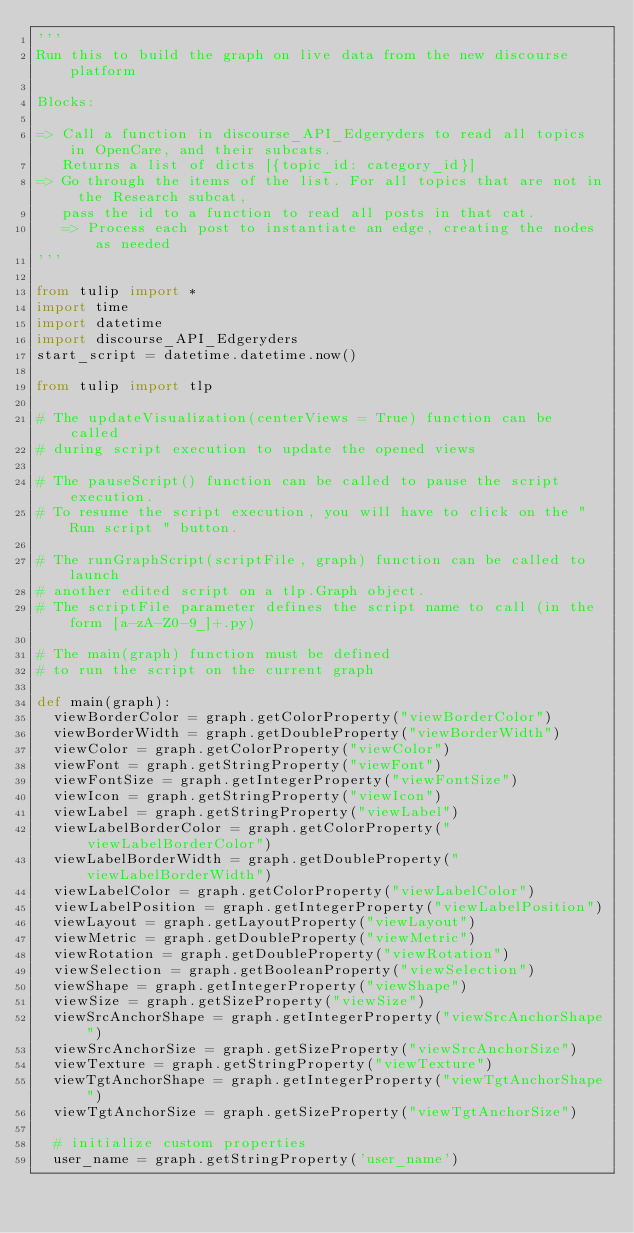<code> <loc_0><loc_0><loc_500><loc_500><_Python_>'''
Run this to build the graph on live data from the new discourse platform

Blocks:

=> Call a function in discourse_API_Edgeryders to read all topics in OpenCare, and their subcats. 
   Returns a list of dicts [{topic_id: category_id}]
=> Go through the items of the list. For all topics that are not in the Research subcat, 
   pass the id to a function to read all posts in that cat.
   => Process each post to instantiate an edge, creating the nodes as needed
'''

from tulip import *
import time
import datetime
import discourse_API_Edgeryders
start_script = datetime.datetime.now()

from tulip import tlp

# The updateVisualization(centerViews = True) function can be called
# during script execution to update the opened views

# The pauseScript() function can be called to pause the script execution.
# To resume the script execution, you will have to click on the "Run script " button.

# The runGraphScript(scriptFile, graph) function can be called to launch
# another edited script on a tlp.Graph object.
# The scriptFile parameter defines the script name to call (in the form [a-zA-Z0-9_]+.py)

# The main(graph) function must be defined 
# to run the script on the current graph

def main(graph): 
  viewBorderColor = graph.getColorProperty("viewBorderColor")
  viewBorderWidth = graph.getDoubleProperty("viewBorderWidth")
  viewColor = graph.getColorProperty("viewColor")
  viewFont = graph.getStringProperty("viewFont")
  viewFontSize = graph.getIntegerProperty("viewFontSize")
  viewIcon = graph.getStringProperty("viewIcon")
  viewLabel = graph.getStringProperty("viewLabel")
  viewLabelBorderColor = graph.getColorProperty("viewLabelBorderColor")
  viewLabelBorderWidth = graph.getDoubleProperty("viewLabelBorderWidth")
  viewLabelColor = graph.getColorProperty("viewLabelColor")
  viewLabelPosition = graph.getIntegerProperty("viewLabelPosition")
  viewLayout = graph.getLayoutProperty("viewLayout")
  viewMetric = graph.getDoubleProperty("viewMetric")
  viewRotation = graph.getDoubleProperty("viewRotation")
  viewSelection = graph.getBooleanProperty("viewSelection")
  viewShape = graph.getIntegerProperty("viewShape")
  viewSize = graph.getSizeProperty("viewSize")
  viewSrcAnchorShape = graph.getIntegerProperty("viewSrcAnchorShape")
  viewSrcAnchorSize = graph.getSizeProperty("viewSrcAnchorSize")
  viewTexture = graph.getStringProperty("viewTexture")
  viewTgtAnchorShape = graph.getIntegerProperty("viewTgtAnchorShape")
  viewTgtAnchorSize = graph.getSizeProperty("viewTgtAnchorSize")

  # initialize custom properties
  user_name = graph.getStringProperty('user_name')</code> 